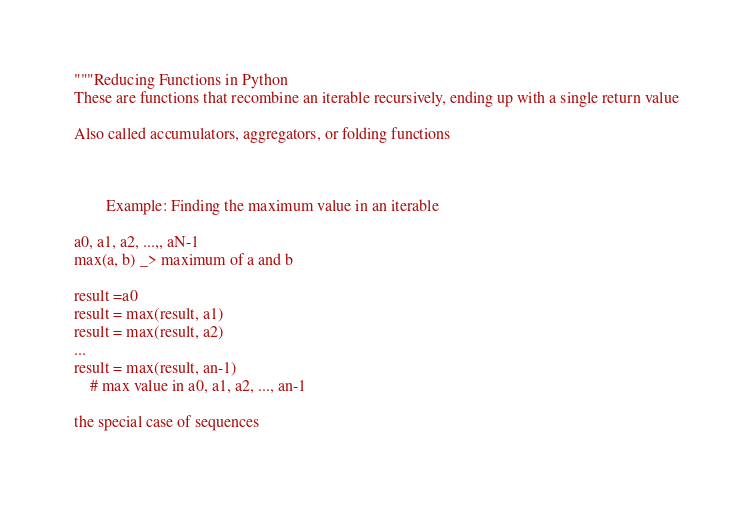Convert code to text. <code><loc_0><loc_0><loc_500><loc_500><_Python_>"""Reducing Functions in Python
These are functions that recombine an iterable recursively, ending up with a single return value

Also called accumulators, aggregators, or folding functions



        Example: Finding the maximum value in an iterable

a0, a1, a2, ...,, aN-1
max(a, b) _> maximum of a and b

result =a0
result = max(result, a1)
result = max(result, a2)
...
result = max(result, an-1)
    # max value in a0, a1, a2, ..., an-1

the special case of sequences</code> 